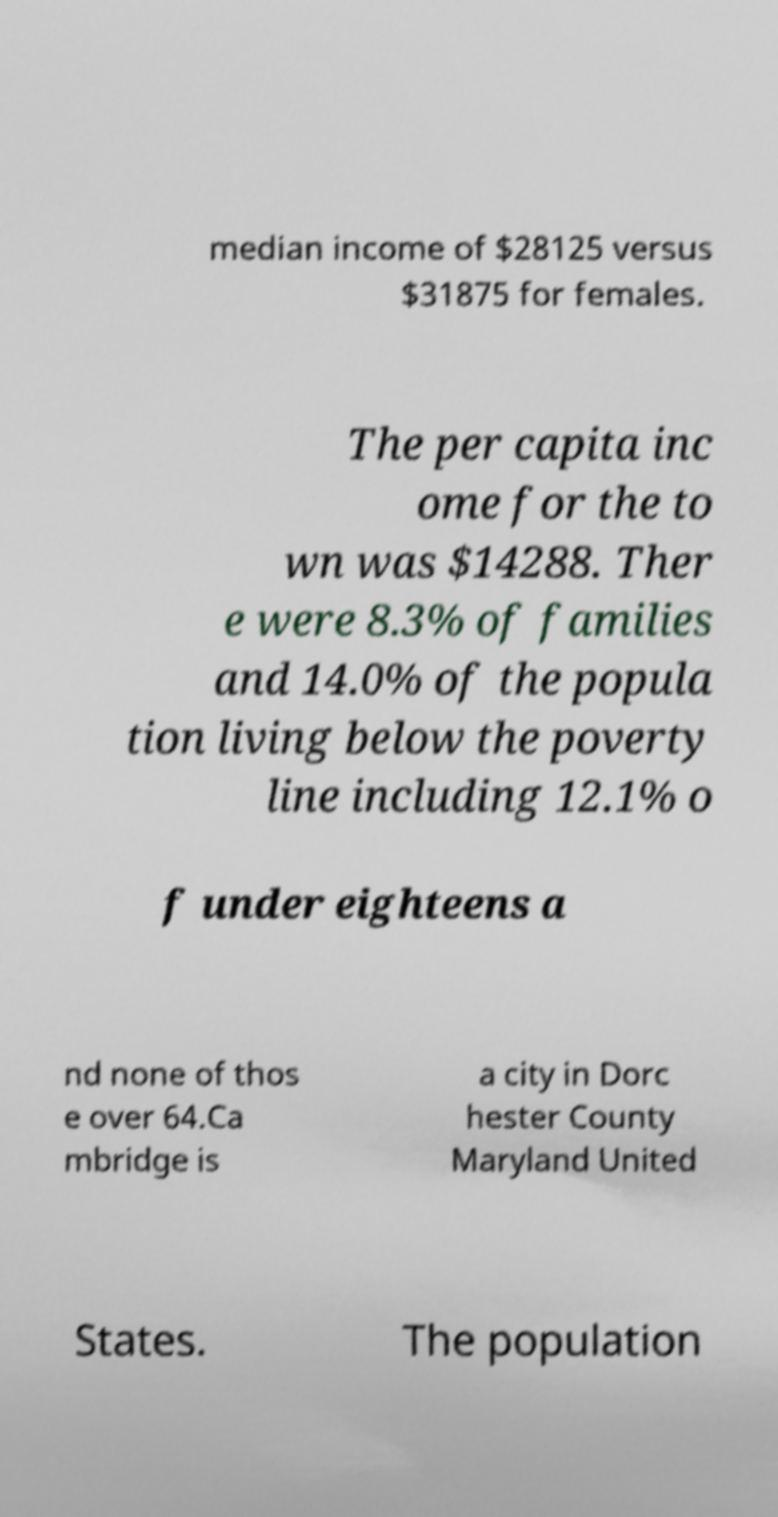Could you assist in decoding the text presented in this image and type it out clearly? median income of $28125 versus $31875 for females. The per capita inc ome for the to wn was $14288. Ther e were 8.3% of families and 14.0% of the popula tion living below the poverty line including 12.1% o f under eighteens a nd none of thos e over 64.Ca mbridge is a city in Dorc hester County Maryland United States. The population 